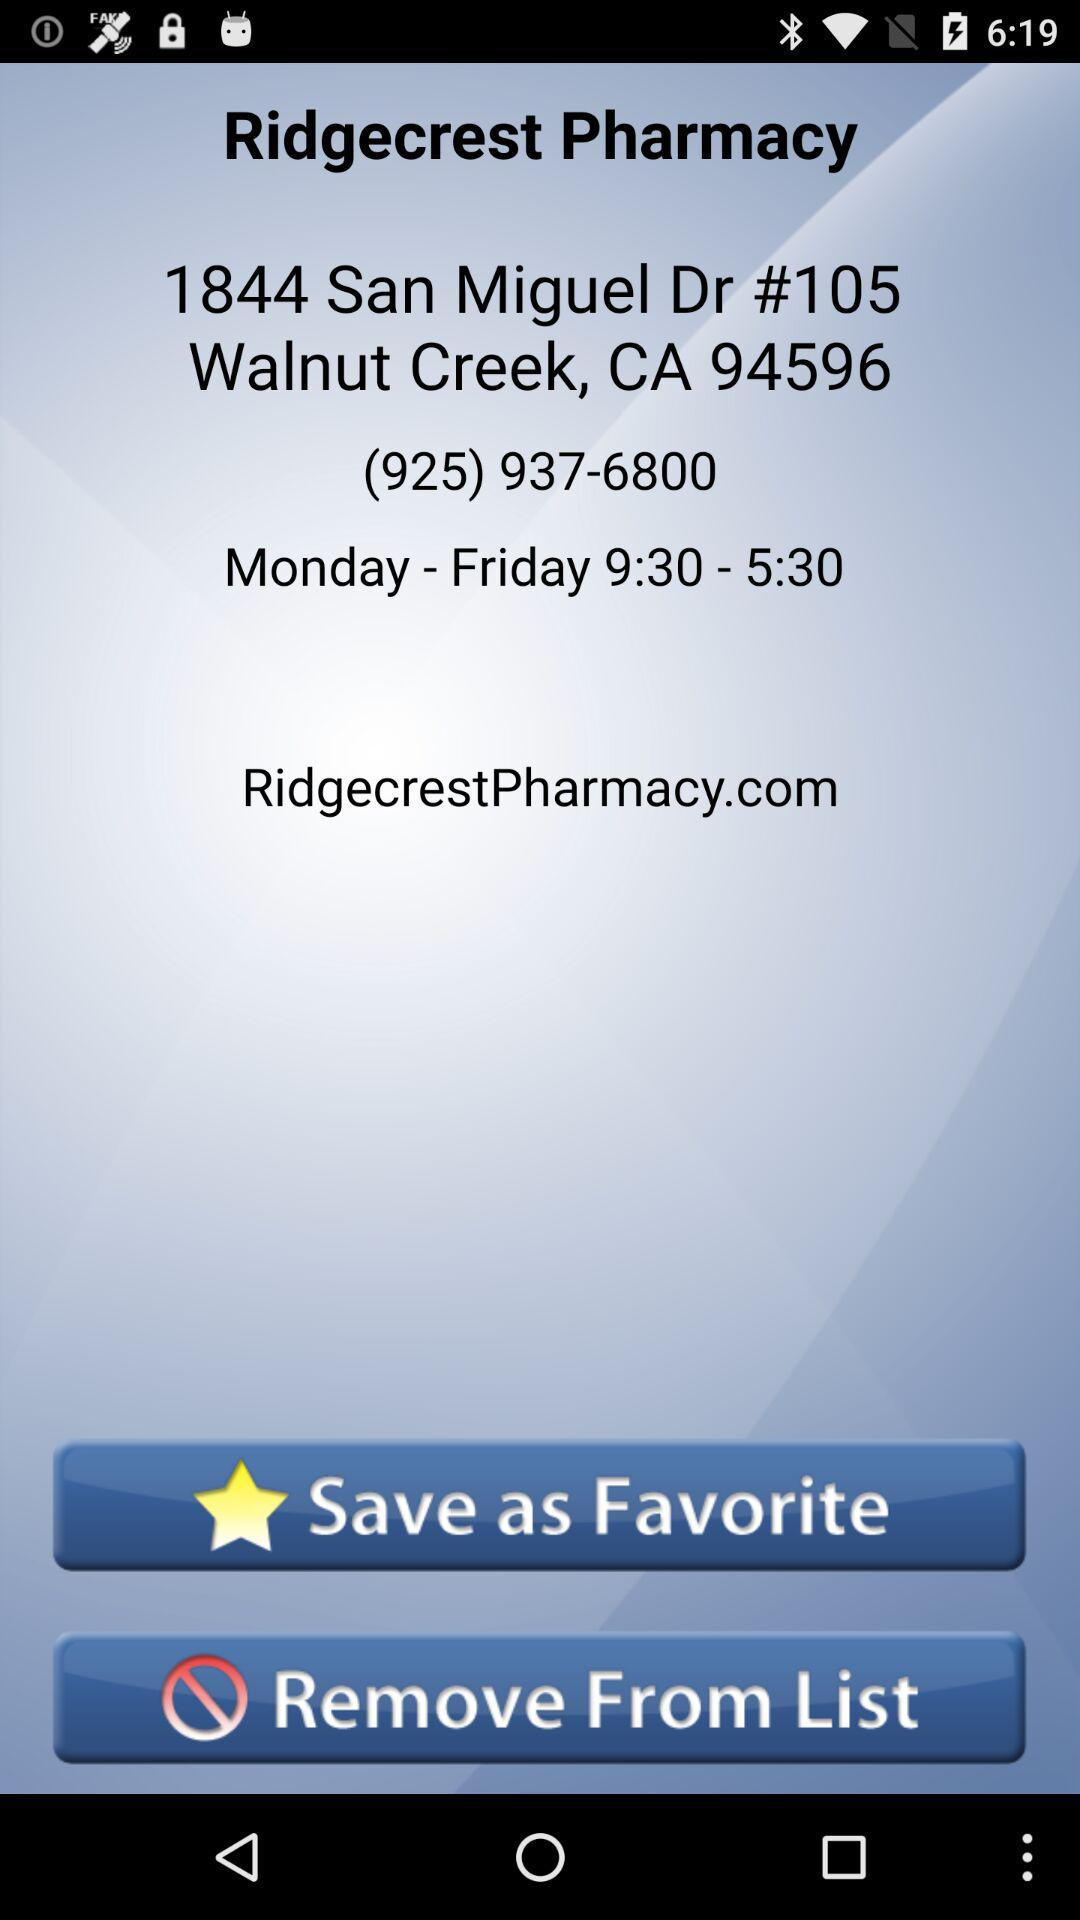What is the address of "Ridgecrest Pharmacy"? The address is 1844 San Miguel Dr #105, Walnut Creek, CA 94596. 